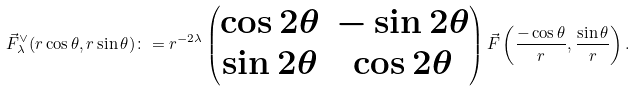Convert formula to latex. <formula><loc_0><loc_0><loc_500><loc_500>\vec { F } ^ { \vee } _ { \lambda } ( r \cos \theta , r \sin \theta ) \colon = r ^ { - 2 \lambda } \begin{pmatrix} \cos 2 \theta & - \sin 2 \theta \\ \sin 2 \theta & \cos 2 \theta \end{pmatrix} \vec { F } \left ( \frac { - \cos \theta } { r } , \frac { \sin \theta } { r } \right ) .</formula> 